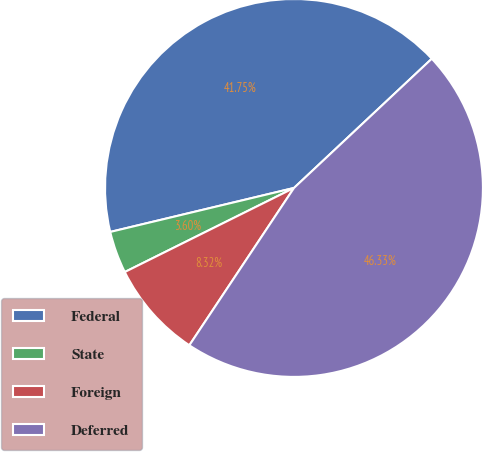Convert chart. <chart><loc_0><loc_0><loc_500><loc_500><pie_chart><fcel>Federal<fcel>State<fcel>Foreign<fcel>Deferred<nl><fcel>41.75%<fcel>3.6%<fcel>8.32%<fcel>46.33%<nl></chart> 